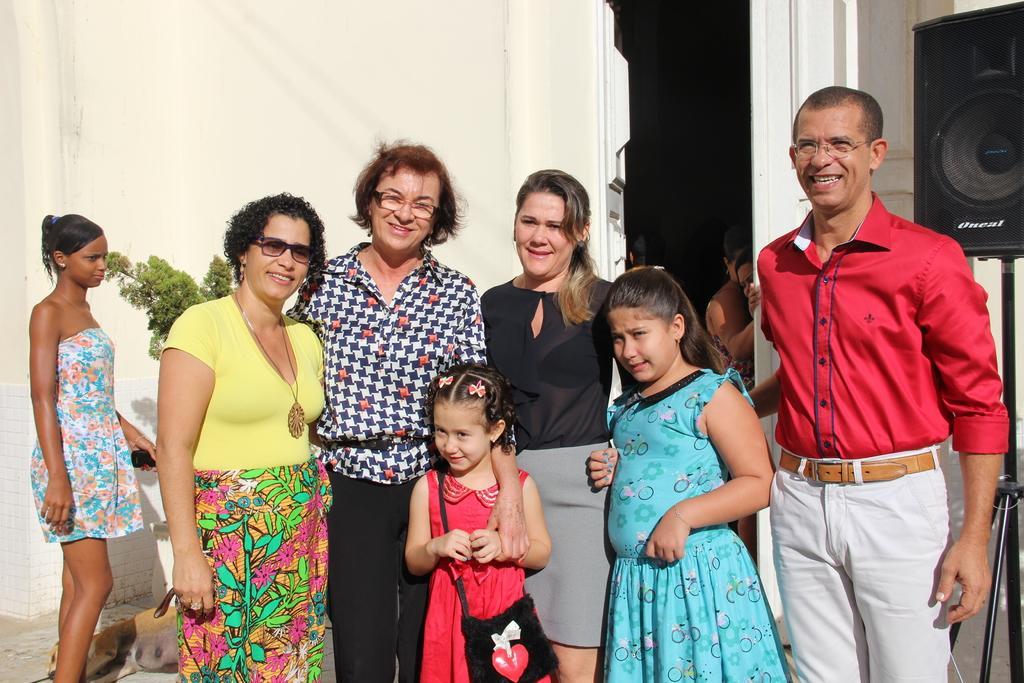How would you summarize this image in a sentence or two? In this image there are a few people standing. They are smiling. Behind them there is a wall. To the right there is a speaker on a tripod stand. There is a door to the wall. There is a plant in front of the wall. In the background there are a few people. There is a dog sleeping on the ground. 